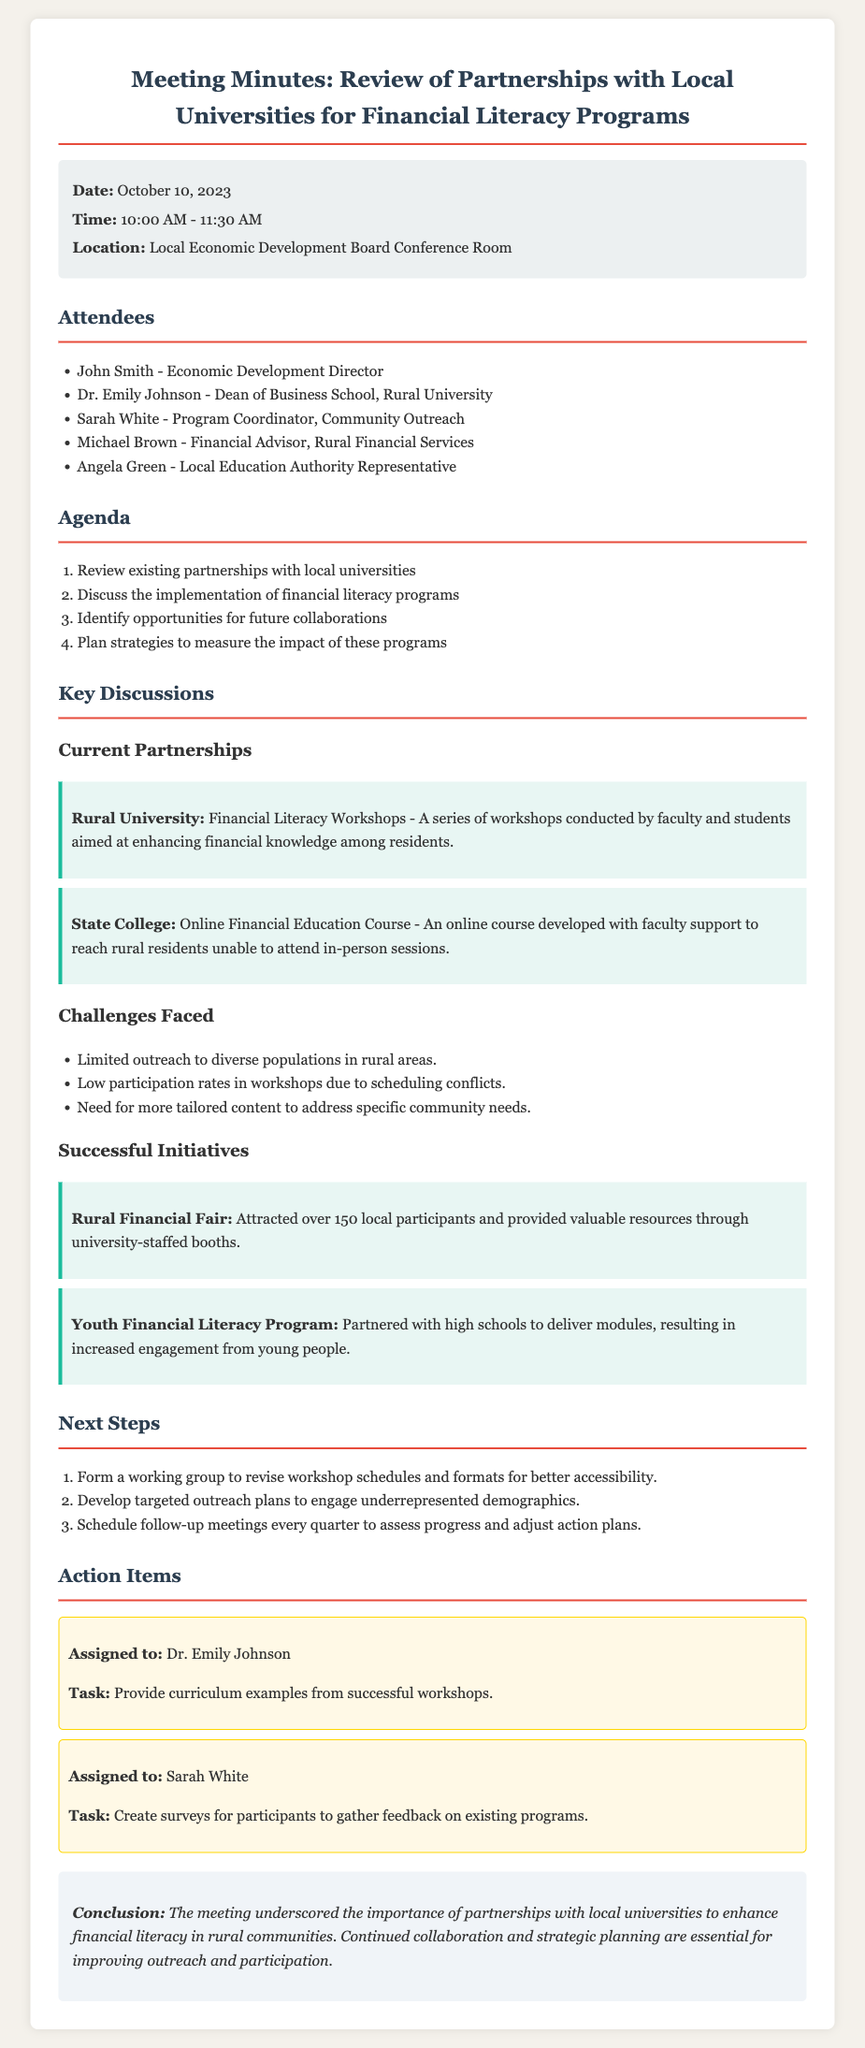What is the date of the meeting? The meeting date is specified in the meta-info section of the document.
Answer: October 10, 2023 Who is the Dean of Business School at Rural University? The attendees list provides the name of the Dean of Business School.
Answer: Dr. Emily Johnson What is a challenge faced in promoting financial literacy programs? The challenges faced are listed in the document, focusing on barriers to outreach and participation.
Answer: Limited outreach to diverse populations in rural areas What successful initiative attracted over 150 local participants? The successful initiatives section mentions this specific event as a notable achievement.
Answer: Rural Financial Fair How many action items were listed? The number of action items can be counted directly from the action items section of the document.
Answer: 2 What is the purpose of the working group mentioned in the "Next Steps"? The context provides a reason for forming the group regarding accessibility issues in workshops.
Answer: Revise workshop schedules and formats for better accessibility How often will follow-up meetings be scheduled? The next steps section details the scheduling frequency for these meetings.
Answer: Every quarter What task is assigned to Sarah White? The action items section specifies the task for each assigned person.
Answer: Create surveys for participants to gather feedback on existing programs 